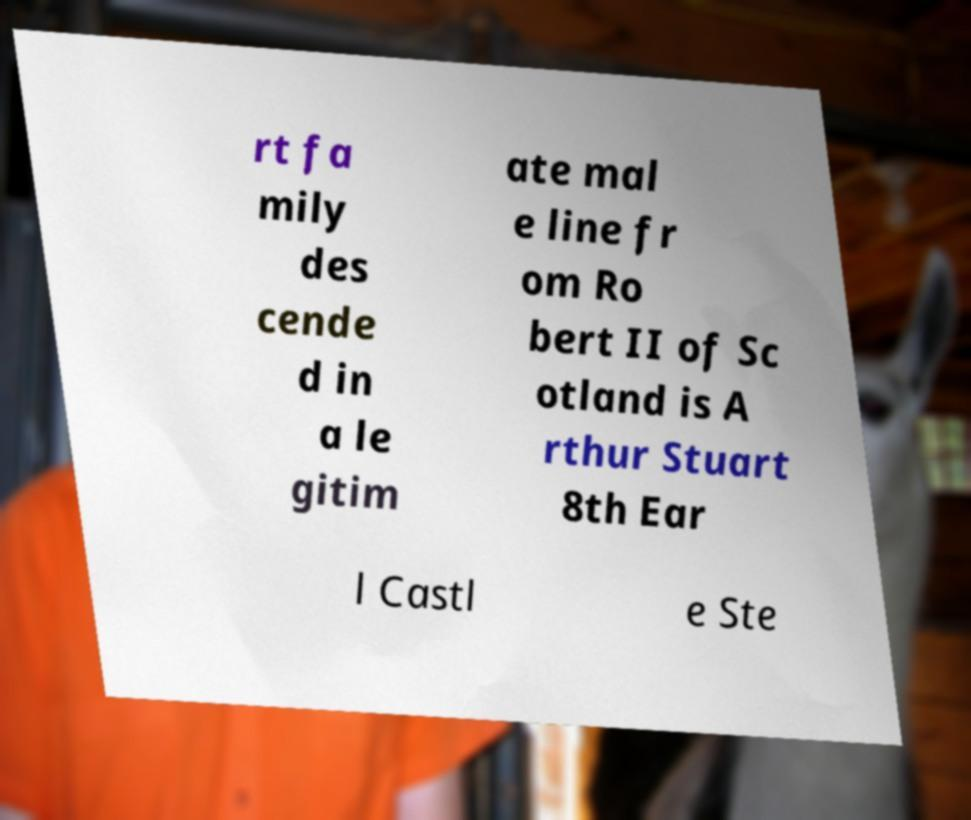Can you accurately transcribe the text from the provided image for me? rt fa mily des cende d in a le gitim ate mal e line fr om Ro bert II of Sc otland is A rthur Stuart 8th Ear l Castl e Ste 